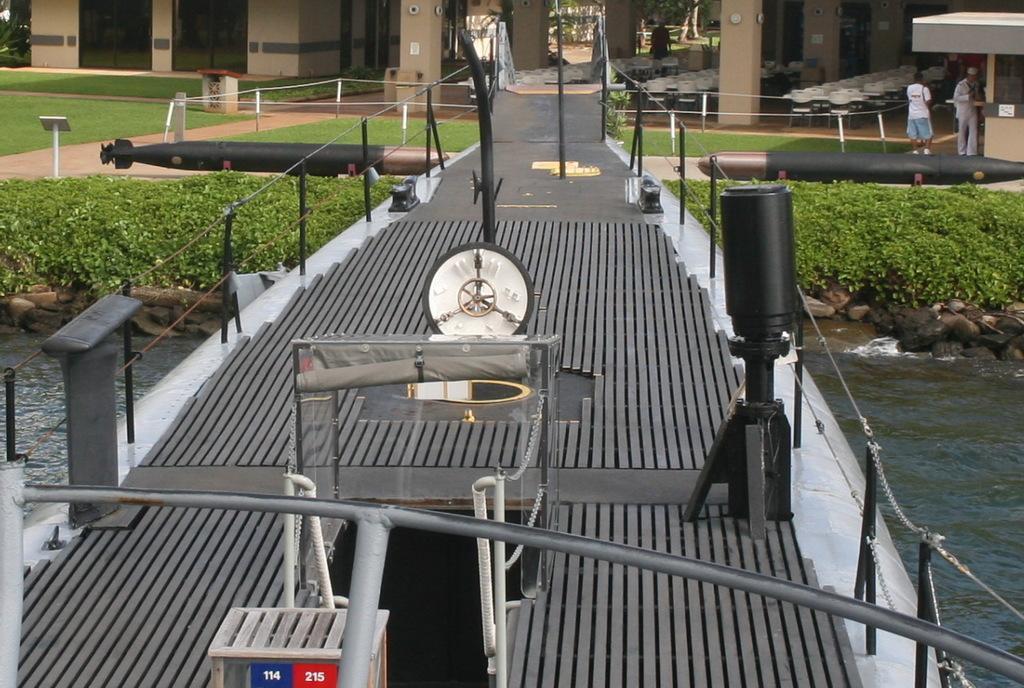Please provide a concise description of this image. In this image there is a bridge in the middle. Under the bridge there is water. There is a clock in the middle of the bridge. In front of the clock there is a glass. In the background there is a building. Under the building there are chairs in the cellar. There are small plants on either side of the bridge. 